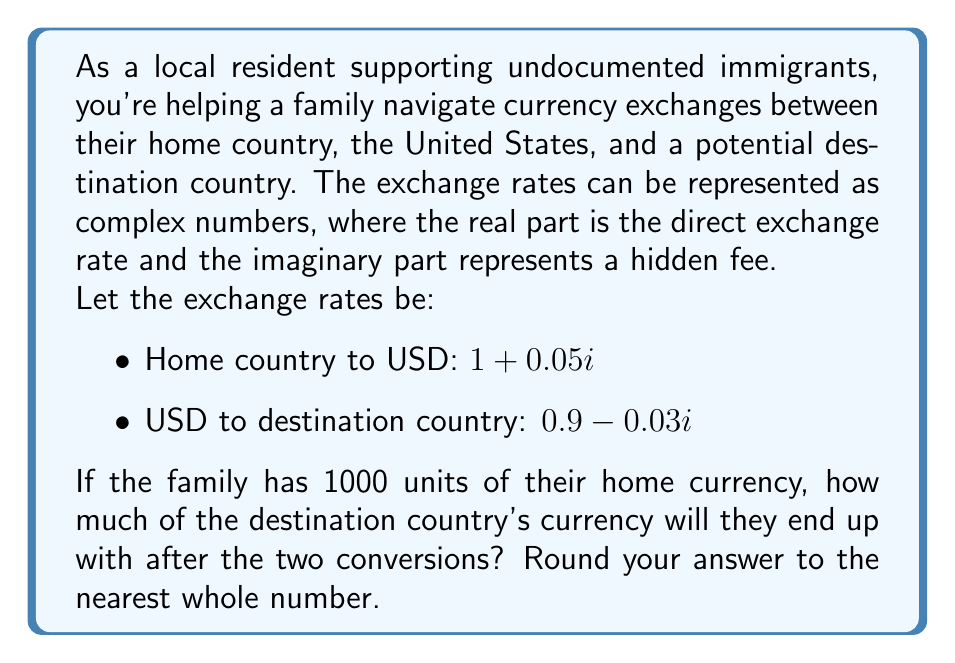Give your solution to this math problem. Let's approach this problem step-by-step:

1) First, we need to convert the home currency to USD. We multiply the amount by the complex exchange rate:

   $1000 * (1 + 0.05i) = 1000 + 50i$

2) Now, we need to convert this USD amount to the destination currency. We multiply the result from step 1 by the second exchange rate:

   $(1000 + 50i) * (0.9 - 0.03i)$

3) To multiply these complex numbers, we use the distributive property:

   $(1000 * 0.9) + (1000 * -0.03i) + (50i * 0.9) + (50i * -0.03i)$

4) Simplify:

   $900 - 30i + 45i - 1.5$

5) Combine like terms:

   $898.5 + 15i$

6) The real part of this complex number represents the amount in the destination currency. The imaginary part represents the total hidden fees in terms of the destination currency.

7) Rounding to the nearest whole number:

   $899$

Thus, after the two conversions, the family will end up with approximately 899 units of the destination country's currency.
Answer: 899 units of the destination country's currency 